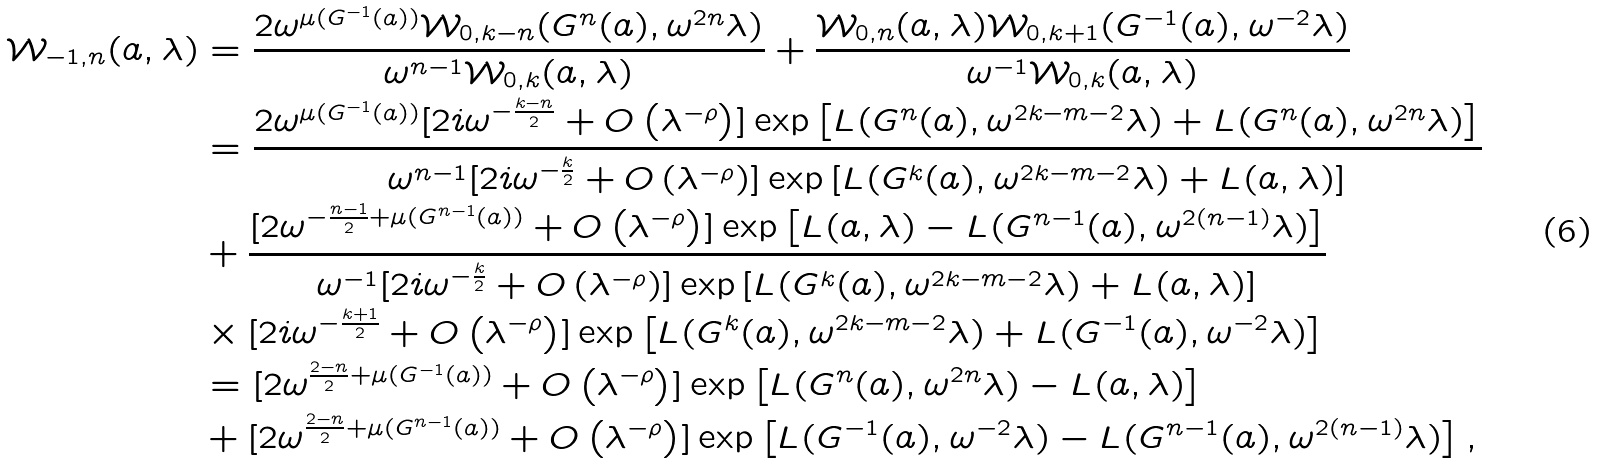<formula> <loc_0><loc_0><loc_500><loc_500>\mathcal { W } _ { - 1 , n } ( a , \lambda ) & = \frac { 2 \omega ^ { \mu ( G ^ { - 1 } ( a ) ) } \mathcal { W } _ { 0 , k - n } ( G ^ { n } ( a ) , \omega ^ { 2 n } \lambda ) } { \omega ^ { n - 1 } \mathcal { W } _ { 0 , k } ( a , \lambda ) } + \frac { \mathcal { W } _ { 0 , n } ( a , \lambda ) \mathcal { W } _ { 0 , k + 1 } ( G ^ { - 1 } ( a ) , \omega ^ { - 2 } \lambda ) } { \omega ^ { - 1 } \mathcal { W } _ { 0 , k } ( a , \lambda ) } \\ & = \frac { 2 \omega ^ { \mu ( G ^ { - 1 } ( a ) ) } [ 2 i \omega ^ { - \frac { k - n } { 2 } } + O \left ( \lambda ^ { - \rho } \right ) ] \exp \left [ L ( G ^ { n } ( a ) , \omega ^ { 2 k - m - 2 } \lambda ) + L ( G ^ { n } ( a ) , \omega ^ { 2 n } \lambda ) \right ] } { \omega ^ { n - 1 } [ 2 i \omega ^ { - \frac { k } { 2 } } + O \left ( \lambda ^ { - \rho } \right ) ] \exp \left [ L ( G ^ { k } ( a ) , \omega ^ { 2 k - m - 2 } \lambda ) + L ( a , \lambda ) \right ] } \\ & + \frac { [ 2 \omega ^ { - \frac { n - 1 } { 2 } + \mu ( G ^ { n - 1 } ( a ) ) } + O \left ( \lambda ^ { - \rho } \right ) ] \exp \left [ L ( a , \lambda ) - L ( G ^ { n - 1 } ( a ) , \omega ^ { 2 ( n - 1 ) } \lambda ) \right ] } { \omega ^ { - 1 } [ 2 i \omega ^ { - \frac { k } { 2 } } + O \left ( \lambda ^ { - \rho } \right ) ] \exp \left [ L ( G ^ { k } ( a ) , \omega ^ { 2 k - m - 2 } \lambda ) + L ( a , \lambda ) \right ] } \\ & \times [ 2 i \omega ^ { - \frac { k + 1 } { 2 } } + O \left ( \lambda ^ { - \rho } \right ) ] \exp \left [ L ( G ^ { k } ( a ) , \omega ^ { 2 k - m - 2 } \lambda ) + L ( G ^ { - 1 } ( a ) , \omega ^ { - 2 } \lambda ) \right ] \\ & = [ 2 \omega ^ { \frac { 2 - n } { 2 } + \mu ( G ^ { - 1 } ( a ) ) } + O \left ( \lambda ^ { - \rho } \right ) ] \exp \left [ L ( G ^ { n } ( a ) , \omega ^ { 2 n } \lambda ) - L ( a , \lambda ) \right ] \\ & + [ 2 \omega ^ { \frac { 2 - n } { 2 } + \mu ( G ^ { n - 1 } ( a ) ) } + O \left ( \lambda ^ { - \rho } \right ) ] \exp \left [ L ( G ^ { - 1 } ( a ) , \omega ^ { - 2 } \lambda ) - L ( G ^ { n - 1 } ( a ) , \omega ^ { 2 ( n - 1 ) } \lambda ) \right ] ,</formula> 